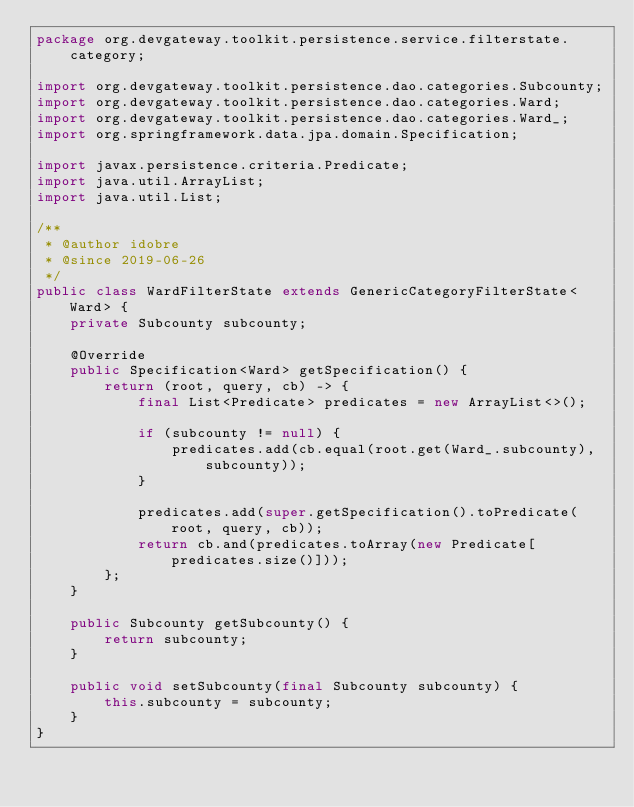Convert code to text. <code><loc_0><loc_0><loc_500><loc_500><_Java_>package org.devgateway.toolkit.persistence.service.filterstate.category;

import org.devgateway.toolkit.persistence.dao.categories.Subcounty;
import org.devgateway.toolkit.persistence.dao.categories.Ward;
import org.devgateway.toolkit.persistence.dao.categories.Ward_;
import org.springframework.data.jpa.domain.Specification;

import javax.persistence.criteria.Predicate;
import java.util.ArrayList;
import java.util.List;

/**
 * @author idobre
 * @since 2019-06-26
 */
public class WardFilterState extends GenericCategoryFilterState<Ward> {
    private Subcounty subcounty;

    @Override
    public Specification<Ward> getSpecification() {
        return (root, query, cb) -> {
            final List<Predicate> predicates = new ArrayList<>();

            if (subcounty != null) {
                predicates.add(cb.equal(root.get(Ward_.subcounty), subcounty));
            }

            predicates.add(super.getSpecification().toPredicate(root, query, cb));
            return cb.and(predicates.toArray(new Predicate[predicates.size()]));
        };
    }

    public Subcounty getSubcounty() {
        return subcounty;
    }

    public void setSubcounty(final Subcounty subcounty) {
        this.subcounty = subcounty;
    }
}</code> 